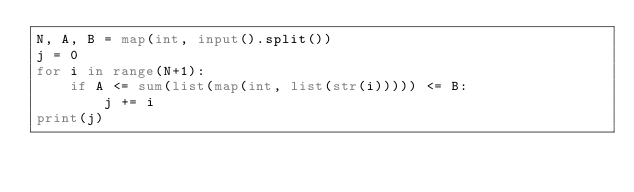Convert code to text. <code><loc_0><loc_0><loc_500><loc_500><_Python_>N, A, B = map(int, input().split())
j = 0
for i in range(N+1):
    if A <= sum(list(map(int, list(str(i))))) <= B:
        j += i
print(j)</code> 